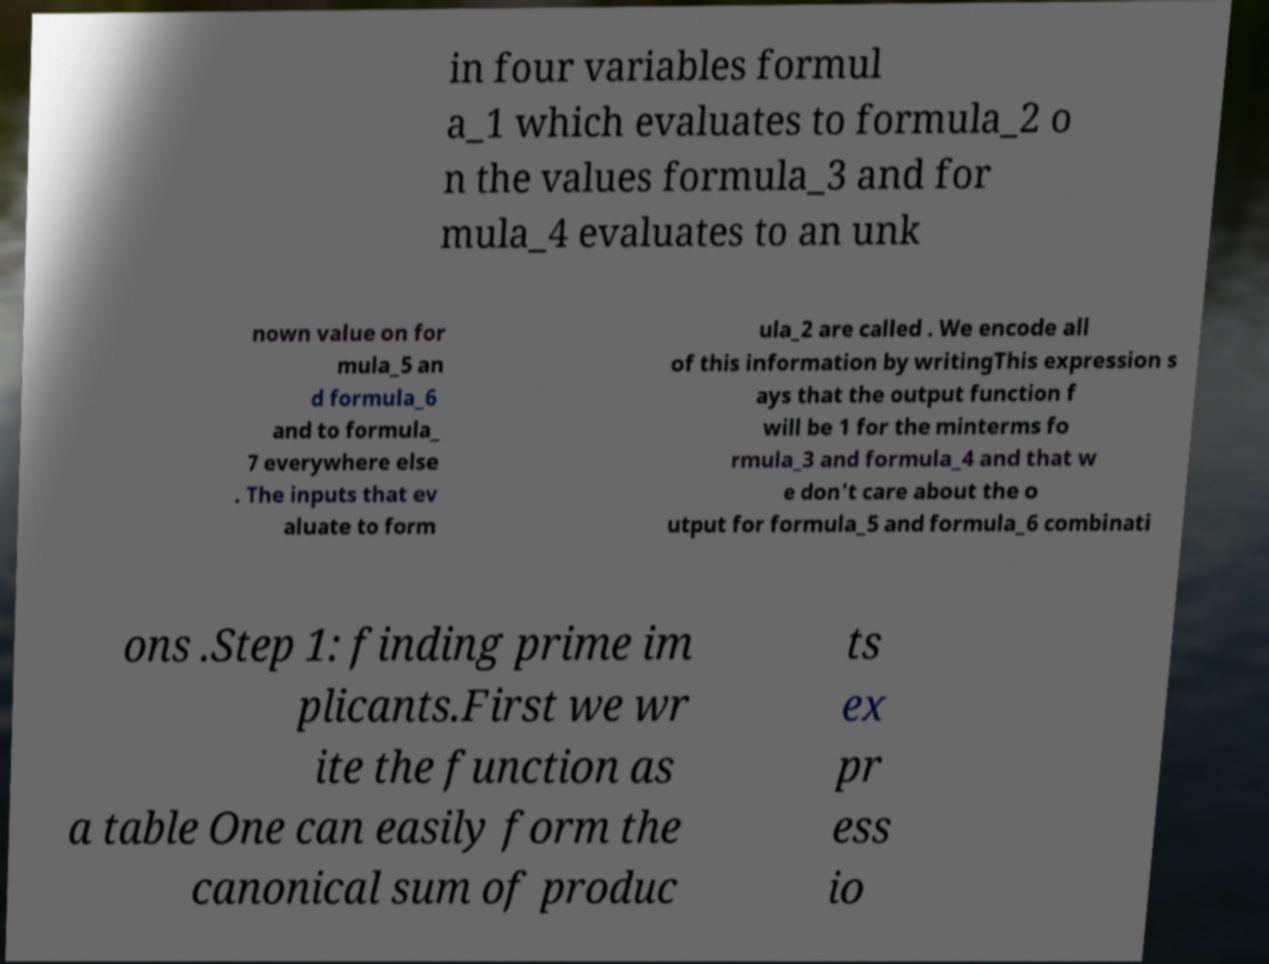Please identify and transcribe the text found in this image. in four variables formul a_1 which evaluates to formula_2 o n the values formula_3 and for mula_4 evaluates to an unk nown value on for mula_5 an d formula_6 and to formula_ 7 everywhere else . The inputs that ev aluate to form ula_2 are called . We encode all of this information by writingThis expression s ays that the output function f will be 1 for the minterms fo rmula_3 and formula_4 and that w e don't care about the o utput for formula_5 and formula_6 combinati ons .Step 1: finding prime im plicants.First we wr ite the function as a table One can easily form the canonical sum of produc ts ex pr ess io 